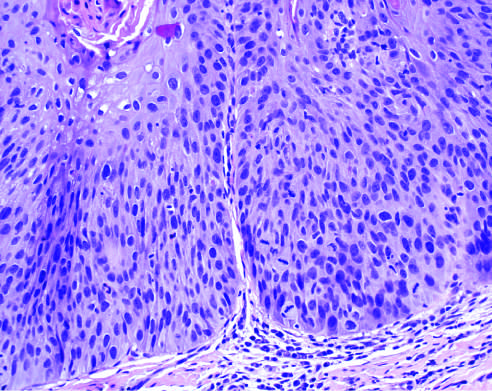s the placenta characterized by nuclear and cellular pleomorphism and loss of normal maturation?
Answer the question using a single word or phrase. No 